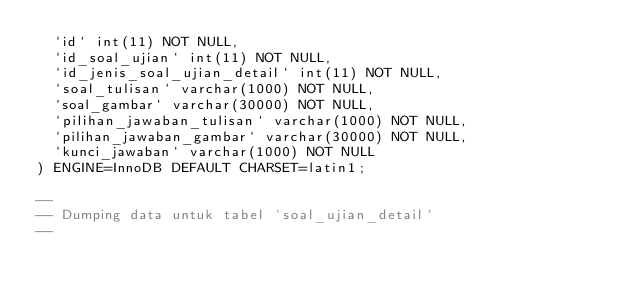Convert code to text. <code><loc_0><loc_0><loc_500><loc_500><_SQL_>  `id` int(11) NOT NULL,
  `id_soal_ujian` int(11) NOT NULL,
  `id_jenis_soal_ujian_detail` int(11) NOT NULL,
  `soal_tulisan` varchar(1000) NOT NULL,
  `soal_gambar` varchar(30000) NOT NULL,
  `pilihan_jawaban_tulisan` varchar(1000) NOT NULL,
  `pilihan_jawaban_gambar` varchar(30000) NOT NULL,
  `kunci_jawaban` varchar(1000) NOT NULL
) ENGINE=InnoDB DEFAULT CHARSET=latin1;

--
-- Dumping data untuk tabel `soal_ujian_detail`
--
</code> 